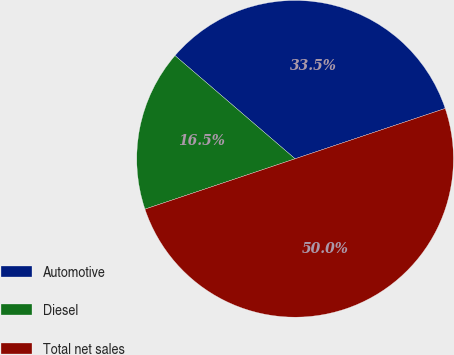<chart> <loc_0><loc_0><loc_500><loc_500><pie_chart><fcel>Automotive<fcel>Diesel<fcel>Total net sales<nl><fcel>33.55%<fcel>16.45%<fcel>50.0%<nl></chart> 